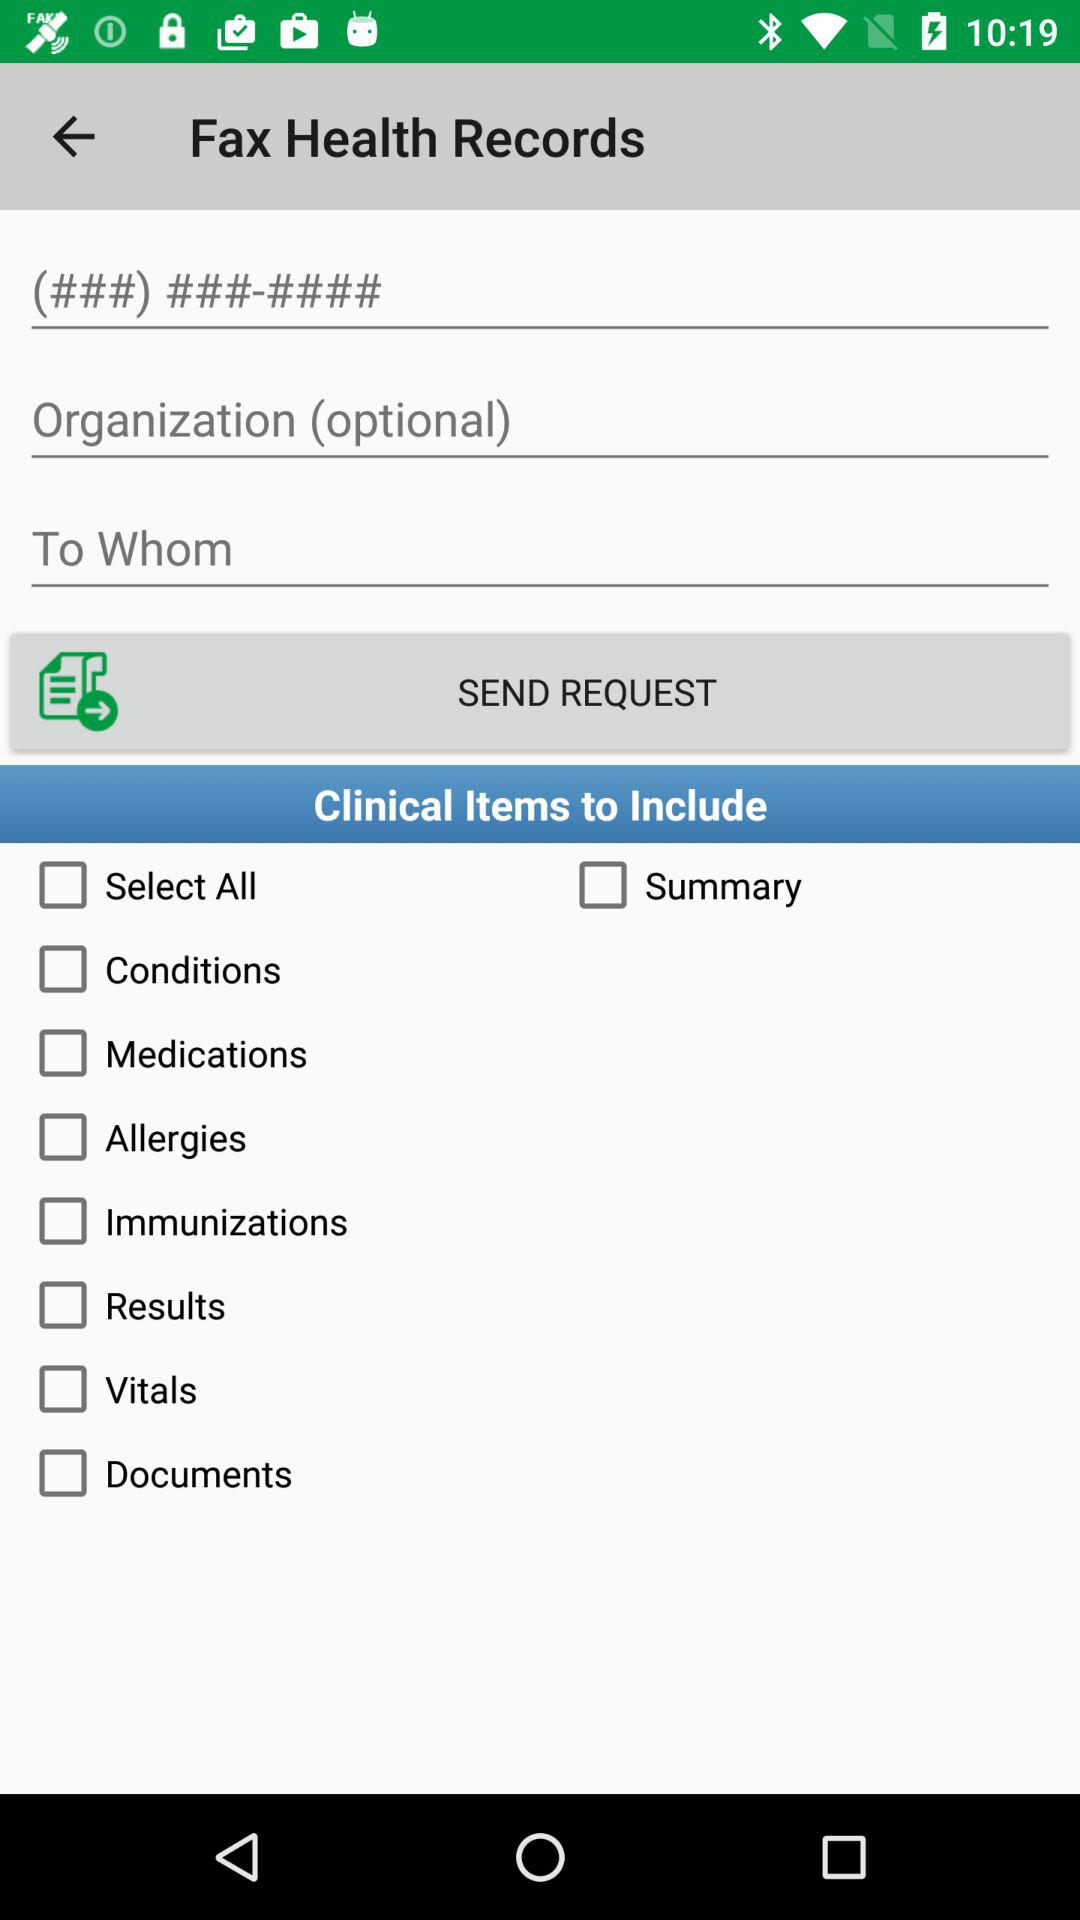How many clinical items are available to include?
Answer the question using a single word or phrase. 9 